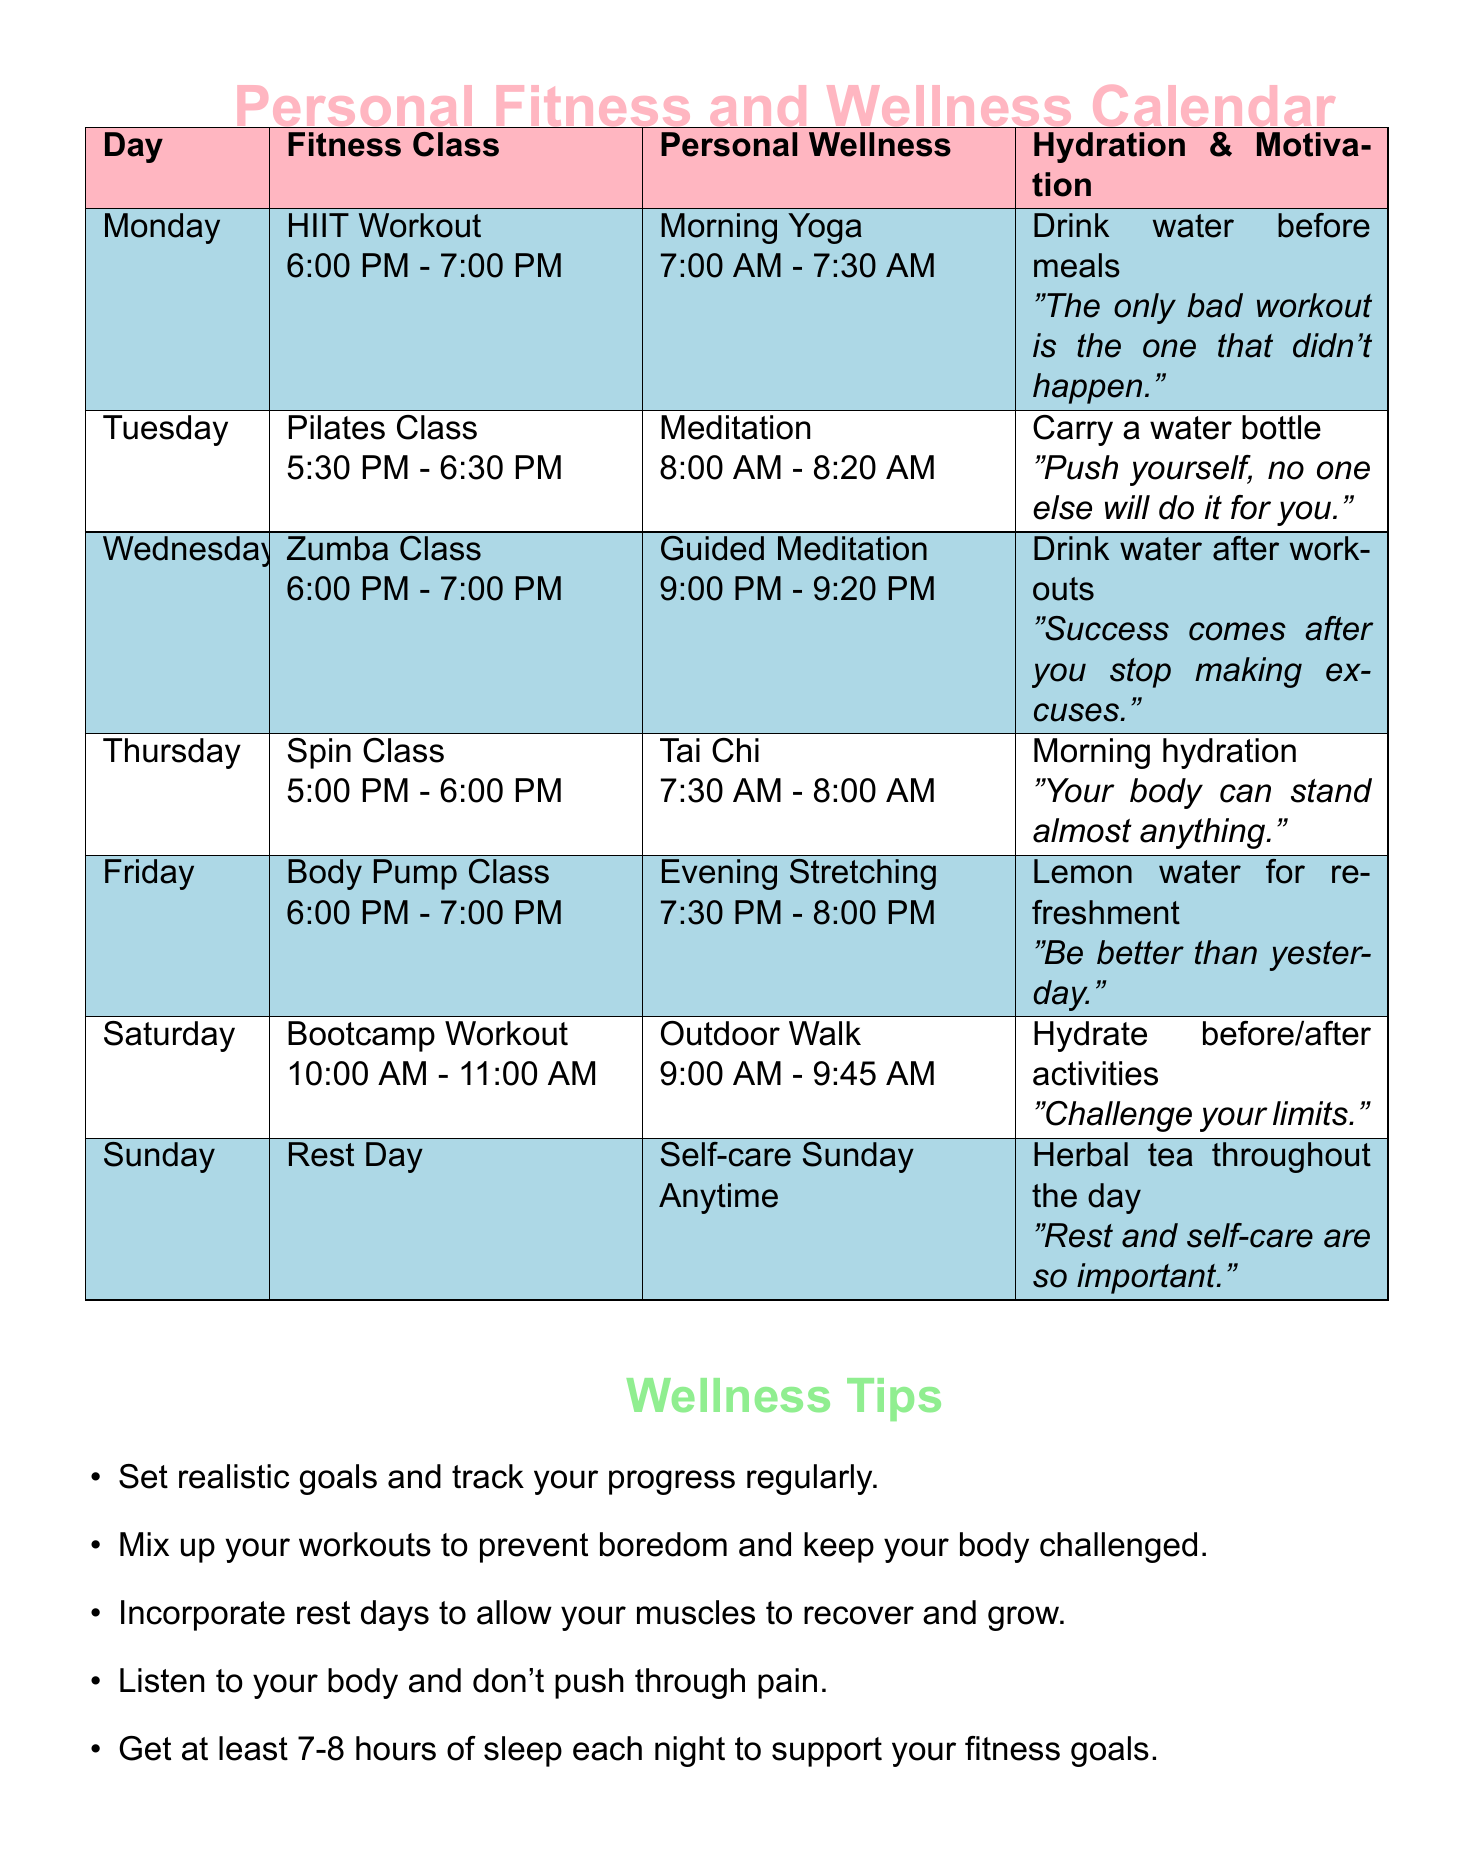What fitness class is scheduled for Monday? The fitness class scheduled for Monday is HIIT Workout from 6:00 PM to 7:00 PM.
Answer: HIIT Workout What time does the Pilates Class start on Tuesday? The Pilates Class on Tuesday starts at 5:30 PM.
Answer: 5:30 PM What wellness activity is listed for Friday? The wellness activity listed for Friday is Evening Stretching from 7:30 PM to 8:00 PM.
Answer: Evening Stretching Which day is designated as a rest day? Sunday is designated as a rest day according to the calendar.
Answer: Sunday What is the motivational quote for Wednesday? The motivational quote for Wednesday is "Success comes after you stop making excuses."
Answer: "Success comes after you stop making excuses." How many hydration reminders are mentioned in the week? There are five hydration reminders mentioned throughout the week, one for each day except Sunday.
Answer: Five What type of class is offered on Saturday? The type of class offered on Saturday is Bootcamp Workout.
Answer: Bootcamp Workout Name one wellness tip provided in the document. One wellness tip provided in the document is to set realistic goals and track your progress regularly.
Answer: Set realistic goals and track your progress regularly What is the duration of the morning yoga session on Monday? The duration of the morning yoga session on Monday is 30 minutes, from 7:00 AM to 7:30 AM.
Answer: 30 minutes 